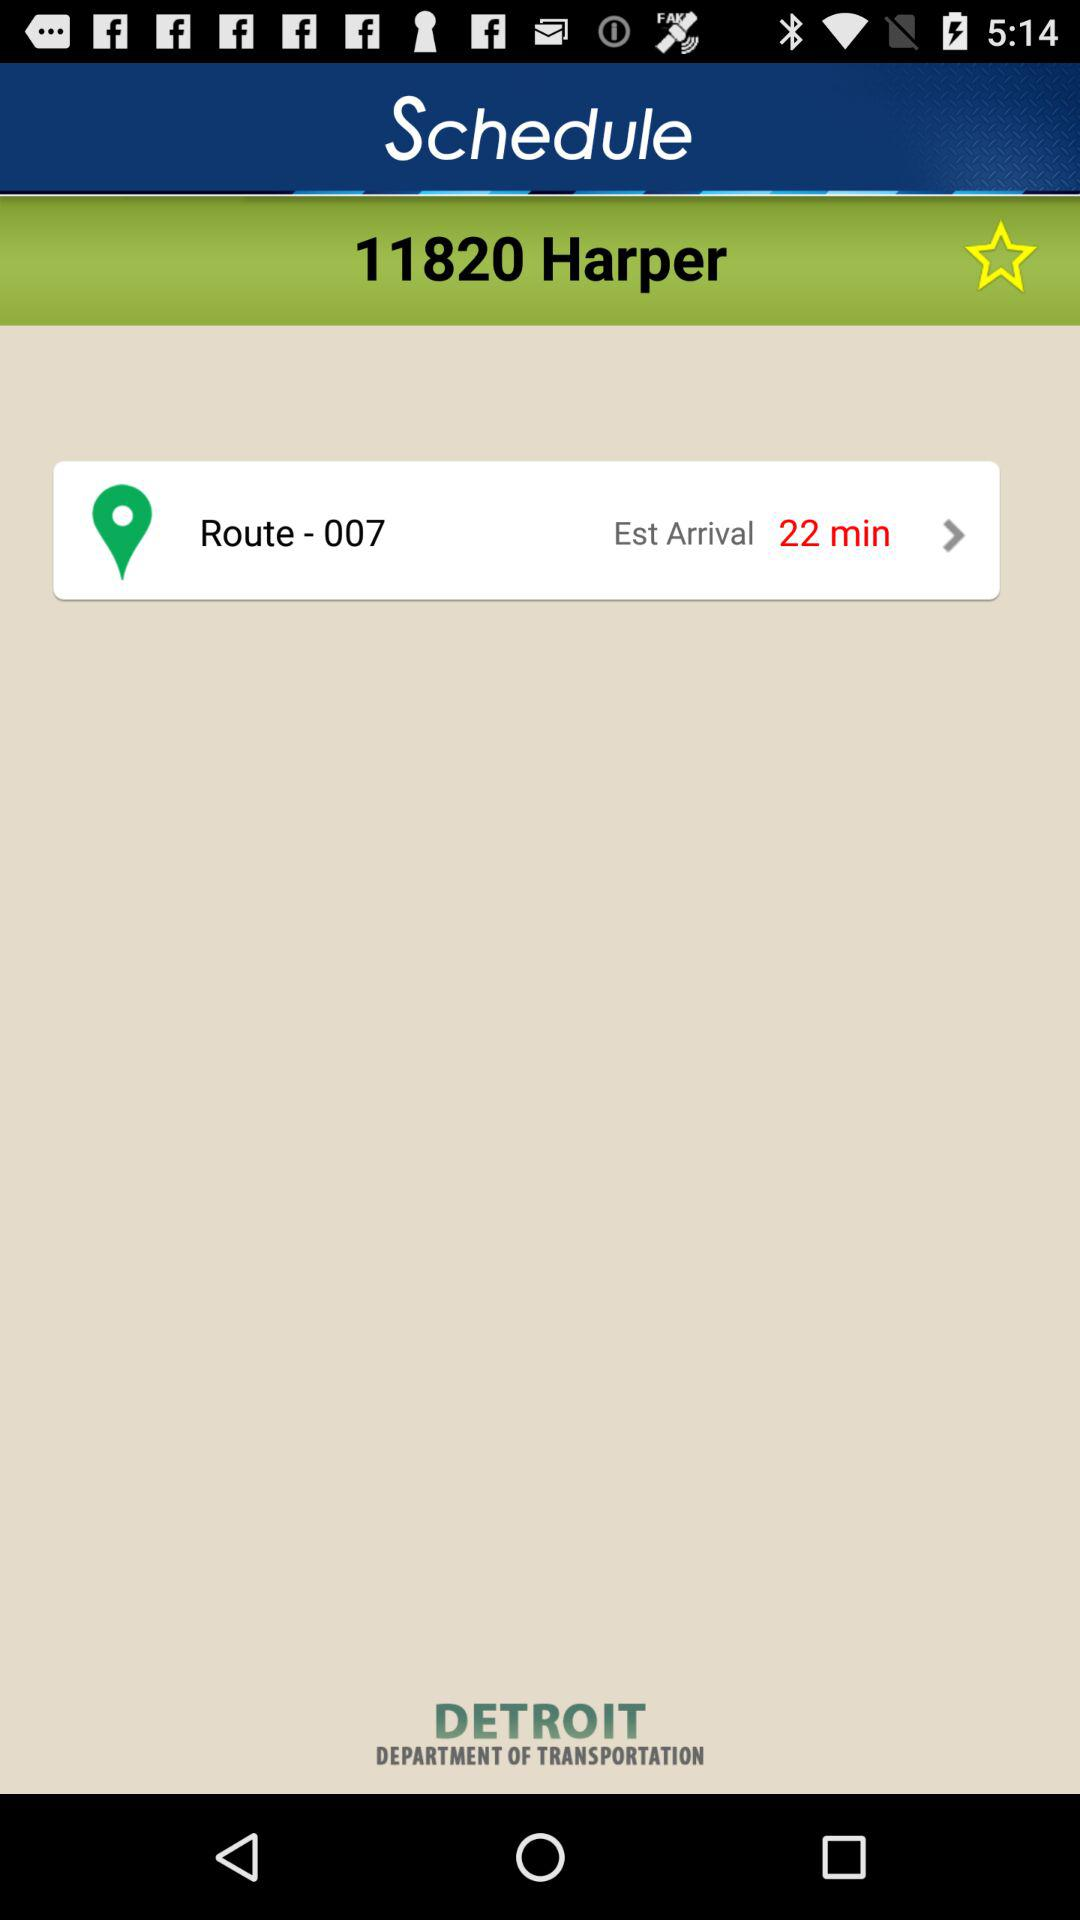What is the number of harpers? The number is 11820 harpers. 